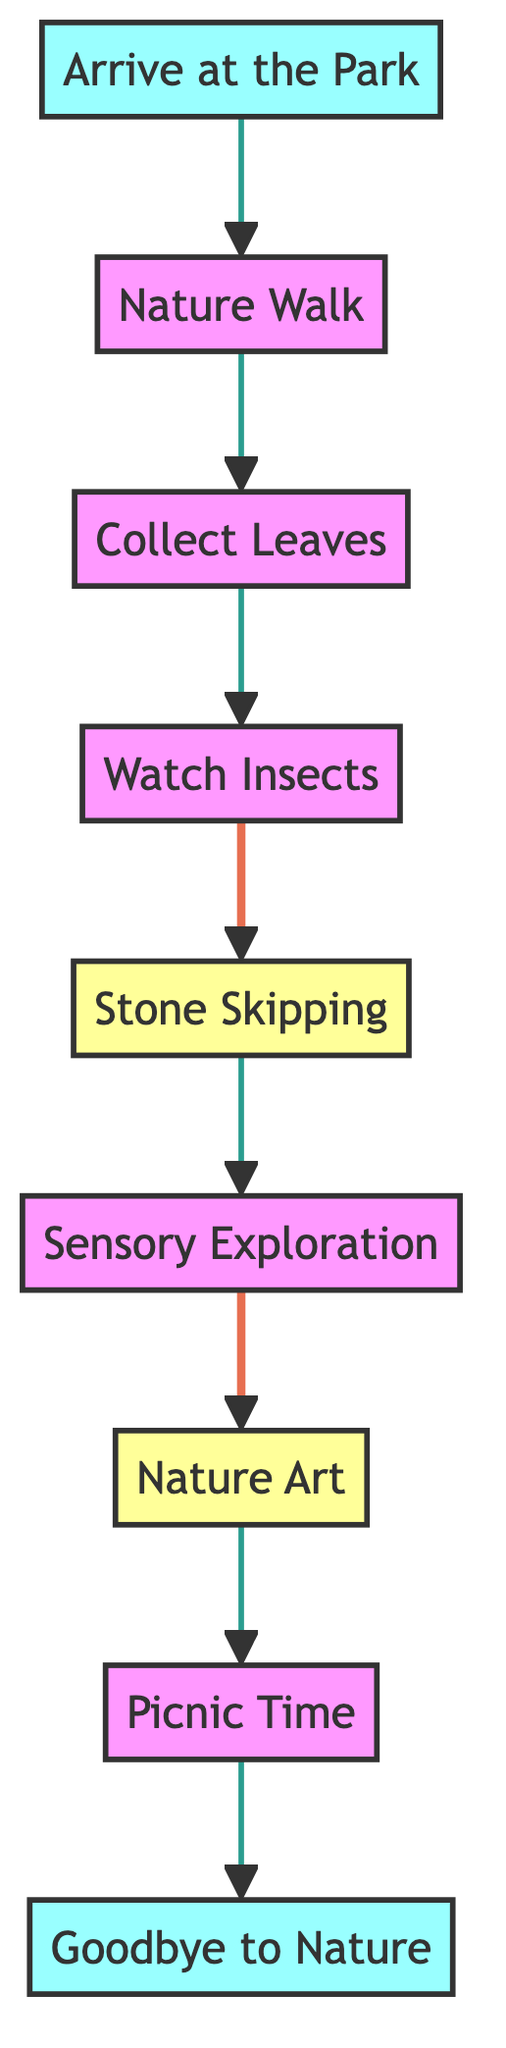What is the first activity in the flow chart? The first activity is labeled "Arrive at the Park." It is the starting point of the adventure, and all other activities are connected to it.
Answer: Arrive at the Park How many activities are there in total? By counting all the distinct activities listed from "Arrive at the Park" to "Goodbye to Nature," there are 9 activities in total.
Answer: 9 What activity follows "Collect Leaves"? The activity that directly follows "Collect Leaves" in the flow chart is "Watch Insects." This connection indicates the sequence of activities.
Answer: Watch Insects Which two activities are highlighted in the diagram? The activities "Stone Skipping" and "Nature Art" are highlighted in the diagram. Highlighting indicates these activities may be of particular importance or fun.
Answer: Stone Skipping, Nature Art What is the last activity in the flow chart? The last activity in the flow chart is "Goodbye to Nature," which signifies the end of the adventure and reflective moment before heading home.
Answer: Goodbye to Nature Which activity comes after "Nature Walk"? After "Nature Walk," the next activity is "Collect Leaves," which continues the exploration of nature following the initial walk.
Answer: Collect Leaves How many activities have sensory exploration in their descriptions? In the flow chart, only one activity, "Sensory Exploration," explicitly focuses on touching various textures as part of the adventure.
Answer: 1 What is the relationship between "Stone Skipping" and "Sensory Exploration"? "Stone Skipping" comes directly after "Sensory Exploration" in the activity flow, suggesting that after exploring textures, participants move on to practicing stone skipping.
Answer: Sequential relationship What does the arrow from "Picnic Time" lead to? The arrow from "Picnic Time" leads to "Goodbye to Nature," indicating that after enjoying the picnic, the next step is to conclude the outdoor adventure.
Answer: Goodbye to Nature 